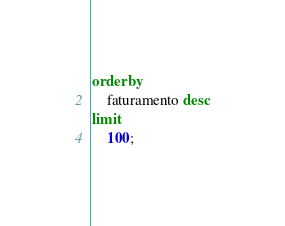Convert code to text. <code><loc_0><loc_0><loc_500><loc_500><_SQL_>order by
	faturamento desc
limit 
	100;
</code> 